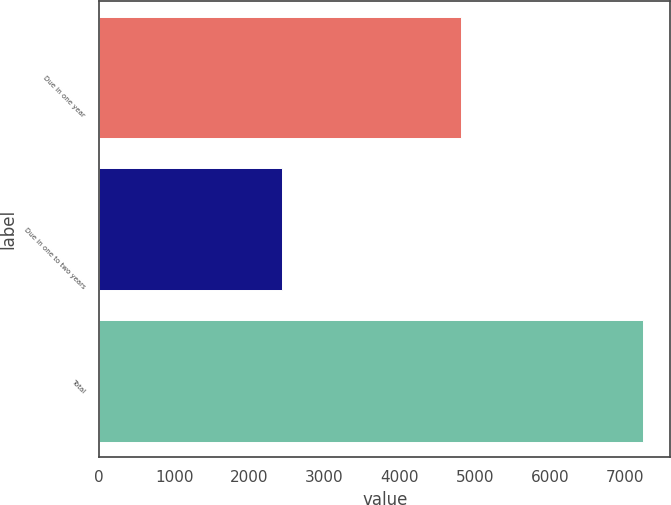<chart> <loc_0><loc_0><loc_500><loc_500><bar_chart><fcel>Due in one year<fcel>Due in one to two years<fcel>Total<nl><fcel>4815<fcel>2427<fcel>7242<nl></chart> 